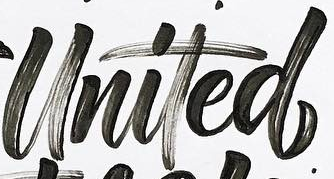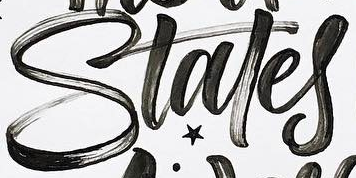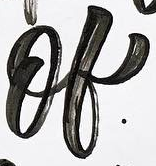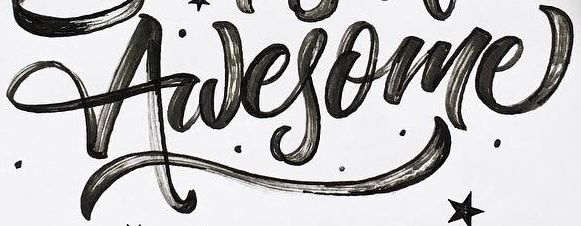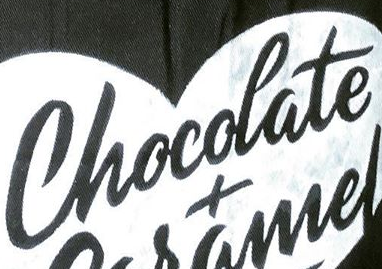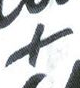Read the text content from these images in order, separated by a semicolon. United; Stales; of; Awesome; Chocolate; + 